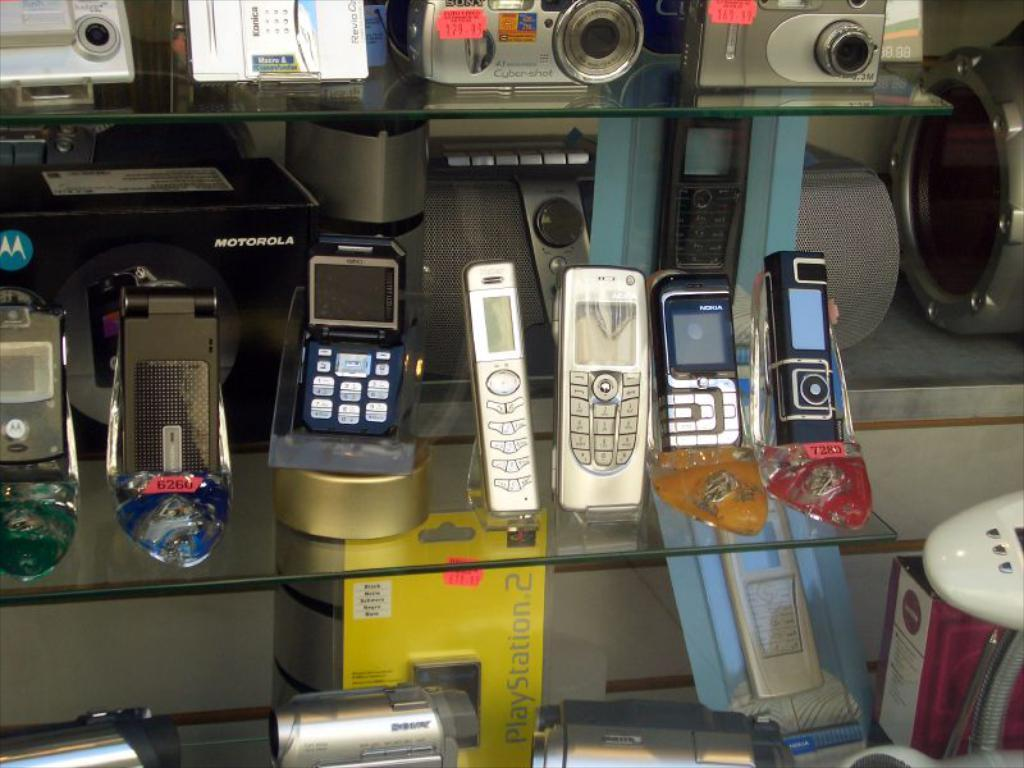<image>
Give a short and clear explanation of the subsequent image. A yellow Playstation 2 box sits on a shelf under some phones. 